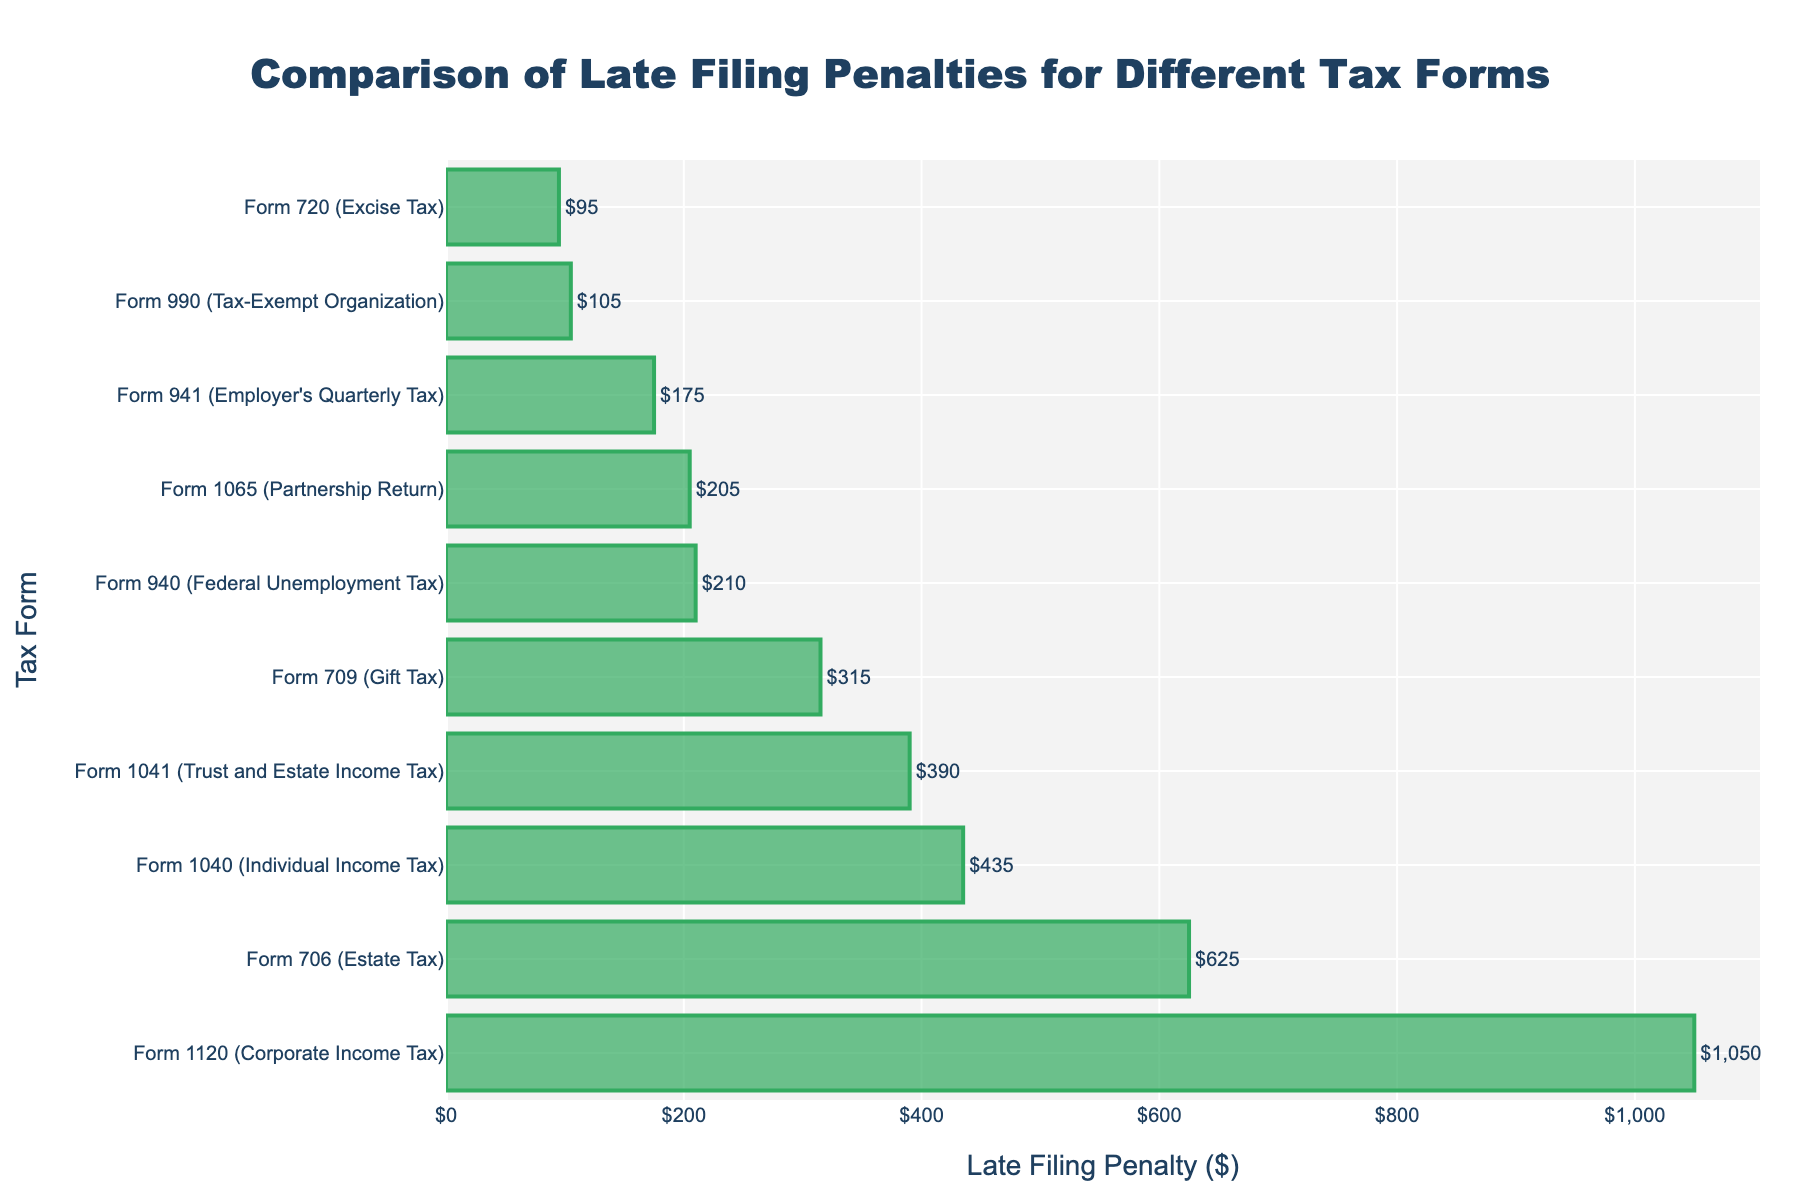What is the tax form with the highest late filing penalty? The form with the highest penalty is observed as the longest bar in the figure. The longest bar corresponds to Form 1120 with a penalty of $1050.
Answer: Form 1120 Which tax forms have penalties greater than $500? By observing the lengths of the bars and their labels, the tax forms with penalties greater than $500 are: Form 1120 ($1050) and Form 706 ($625).
Answer: Form 1120 and Form 706 What is the difference in the late filing penalty between Form 1040 and Form 1041? The penalty for Form 1040 is $435 and for Form 1041 is $390. The difference is calculated as $435 - $390.
Answer: $45 Which tax form has the smallest late filing penalty and how much is it? The tax form with the smallest penalty is identified as the shortest bar, which is Form 720 with a penalty of $95.
Answer: Form 720, $95 What is the average late filing penalty across all tax forms? Sum all penalties and divide by the number of tax forms: ($435 + $1050 + $205 + $390 + $105 + $625 + $315 + $210 + $175 + $95) / 10 = $3605 / 10.
Answer: $360.5 Between Form 1065 and Form 709, which one has a higher late filing penalty and by how much? Form 1065 has a penalty of $205, and Form 709 has $315. The difference is $315 - $205.
Answer: Form 709 by $110 How many tax forms have penalties less than $300? Count the forms with penalties less than $300 by observing the lengths of the bars: Form 720 ($95), Form 990 ($105), Form 941 ($175), and Form 940 ($210).
Answer: 4 What is the combined penalty for Forms 1120, 706, and 1040? Add the penalties for these forms: $1050 (Form 1120) + $625 (Form 706) + $435 (Form 1040).
Answer: $2110 What is the penalty for Form 1041 and how does it compare to the penalty for Form 941? The penalty for Form 1041 is $390, while for Form 941 it is $175. Form 1041's penalty is higher.
Answer: $390 (Form 1041), higher than $175 (Form 941) Which tax forms have penalties less than $200 but more than $100? Observe the lengths of the bars to find forms within this range: Form 990 ($105) and Form 941 ($175).
Answer: Form 990 and Form 941 